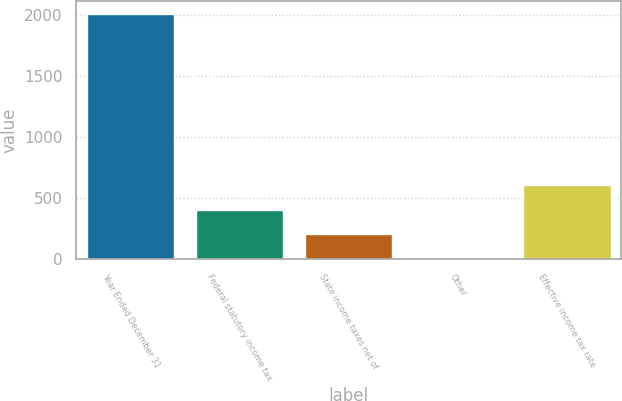Convert chart. <chart><loc_0><loc_0><loc_500><loc_500><bar_chart><fcel>Year Ended December 31<fcel>Federal statutory income tax<fcel>State income taxes net of<fcel>Other<fcel>Effective income tax rate<nl><fcel>2014<fcel>402.96<fcel>201.58<fcel>0.2<fcel>604.34<nl></chart> 